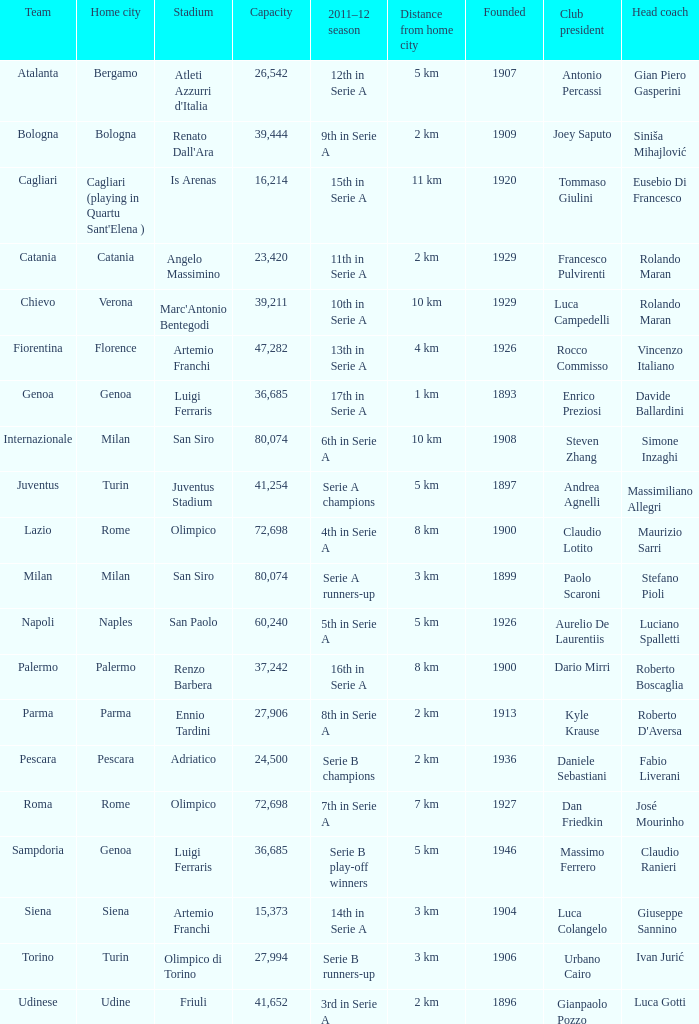What team had a capacity of over 26,542, a home city of milan, and finished the 2011-2012 season 6th in serie a? Internazionale. 